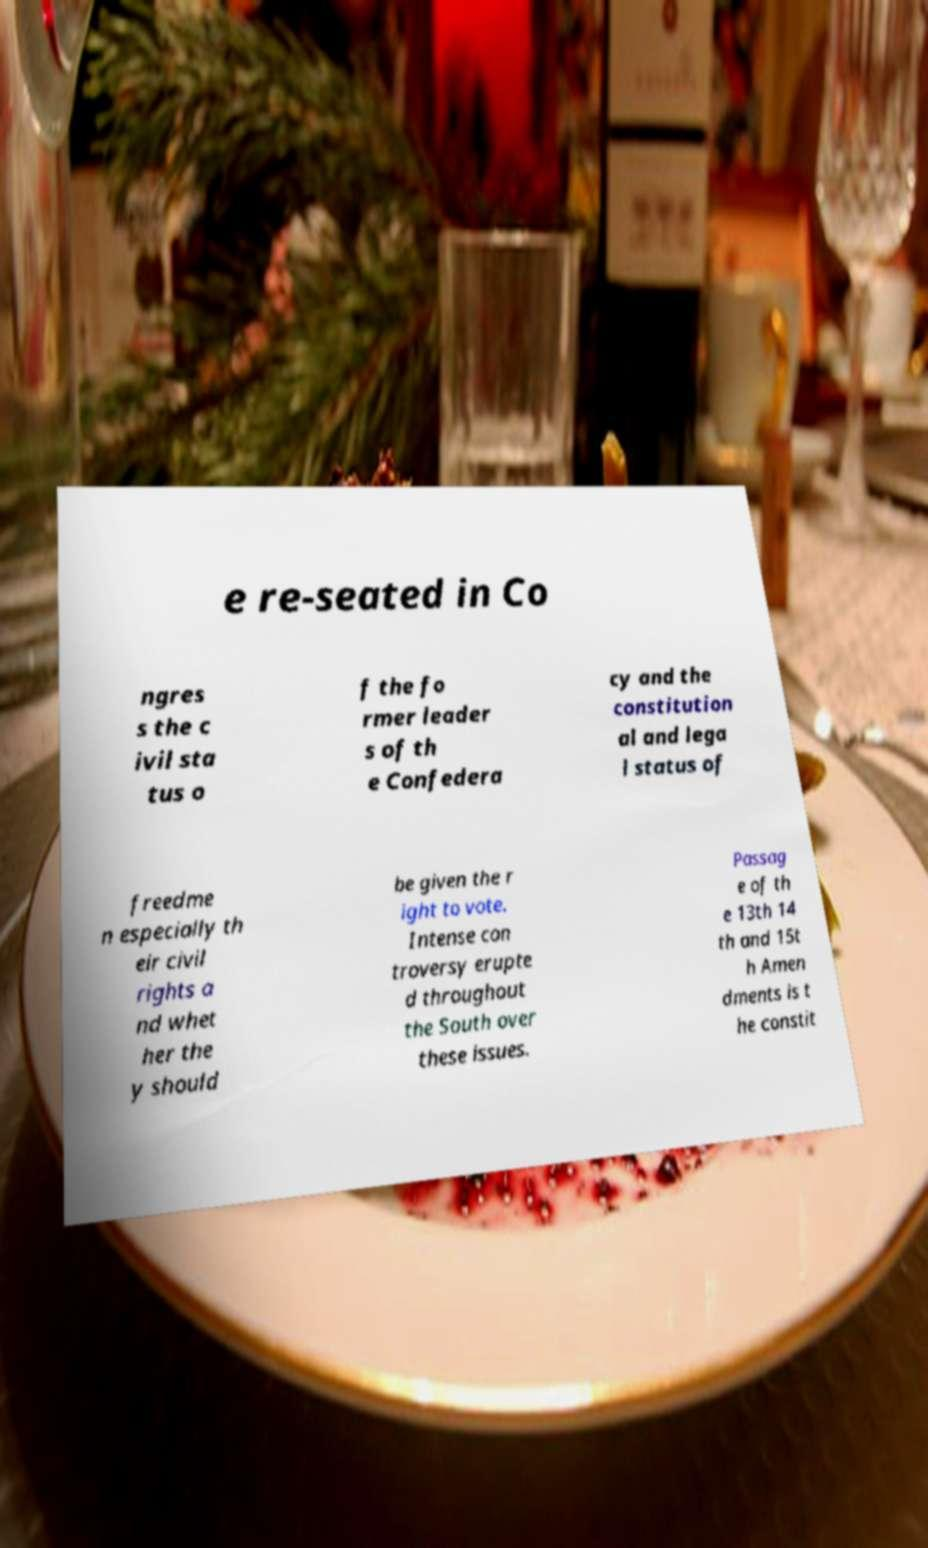There's text embedded in this image that I need extracted. Can you transcribe it verbatim? e re-seated in Co ngres s the c ivil sta tus o f the fo rmer leader s of th e Confedera cy and the constitution al and lega l status of freedme n especially th eir civil rights a nd whet her the y should be given the r ight to vote. Intense con troversy erupte d throughout the South over these issues. Passag e of th e 13th 14 th and 15t h Amen dments is t he constit 